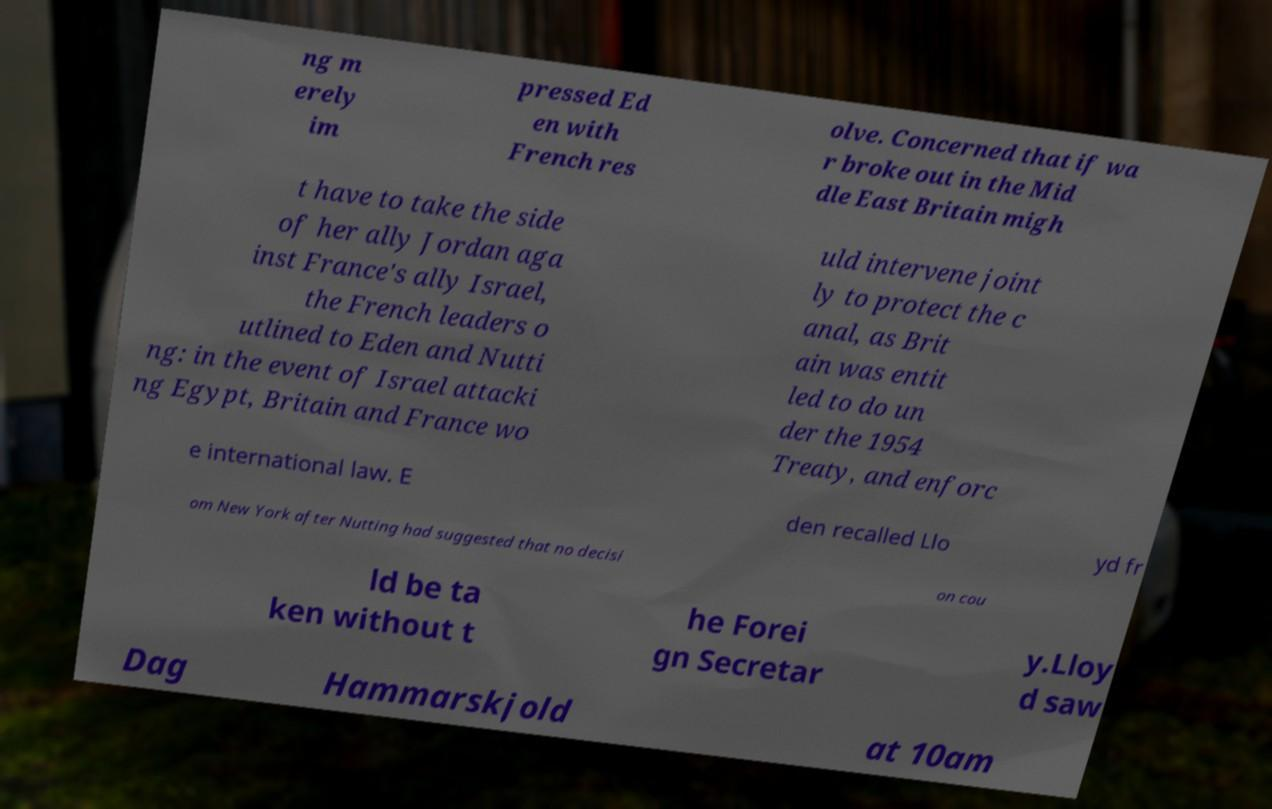For documentation purposes, I need the text within this image transcribed. Could you provide that? ng m erely im pressed Ed en with French res olve. Concerned that if wa r broke out in the Mid dle East Britain migh t have to take the side of her ally Jordan aga inst France's ally Israel, the French leaders o utlined to Eden and Nutti ng: in the event of Israel attacki ng Egypt, Britain and France wo uld intervene joint ly to protect the c anal, as Brit ain was entit led to do un der the 1954 Treaty, and enforc e international law. E den recalled Llo yd fr om New York after Nutting had suggested that no decisi on cou ld be ta ken without t he Forei gn Secretar y.Lloy d saw Dag Hammarskjold at 10am 